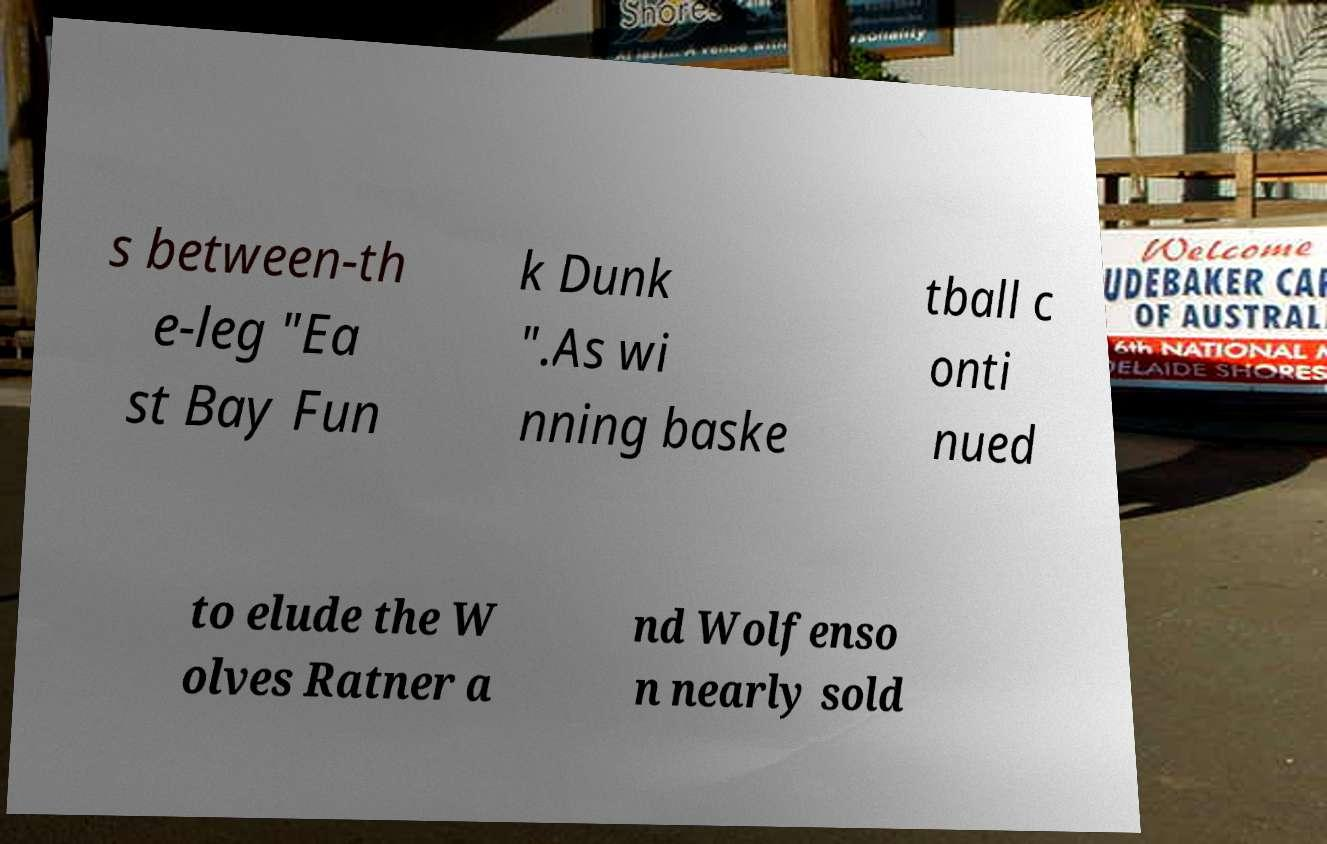For documentation purposes, I need the text within this image transcribed. Could you provide that? s between-th e-leg "Ea st Bay Fun k Dunk ".As wi nning baske tball c onti nued to elude the W olves Ratner a nd Wolfenso n nearly sold 